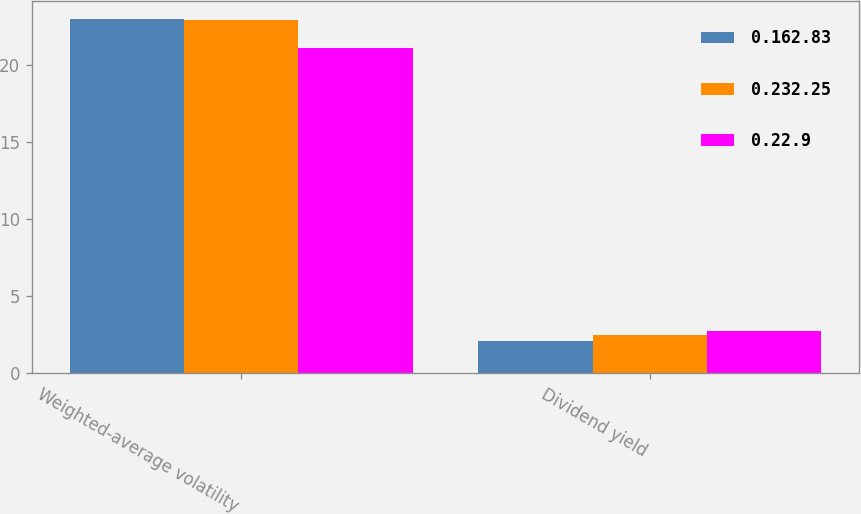Convert chart. <chart><loc_0><loc_0><loc_500><loc_500><stacked_bar_chart><ecel><fcel>Weighted-average volatility<fcel>Dividend yield<nl><fcel>0.162.83<fcel>23<fcel>2.11<nl><fcel>0.232.25<fcel>22.9<fcel>2.46<nl><fcel>0.22.9<fcel>21.1<fcel>2.72<nl></chart> 